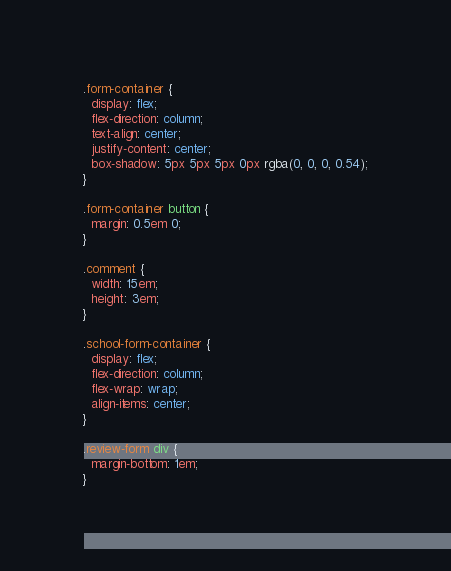Convert code to text. <code><loc_0><loc_0><loc_500><loc_500><_CSS_>.form-container {
  display: flex;
  flex-direction: column;
  text-align: center;
  justify-content: center;
  box-shadow: 5px 5px 5px 0px rgba(0, 0, 0, 0.54);
}

.form-container button {
  margin: 0.5em 0;
}

.comment {
  width: 15em;
  height: 3em;
}

.school-form-container {
  display: flex;
  flex-direction: column;
  flex-wrap: wrap;
  align-items: center;
}

.review-form div {
  margin-bottom: 1em;
}
</code> 